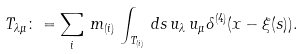Convert formula to latex. <formula><loc_0><loc_0><loc_500><loc_500>T _ { \lambda \mu } \colon = \sum _ { i } \, m _ { ( i ) } \, \int _ { T _ { ( i ) } } \, d s \, u _ { \lambda } \, u _ { \mu } \delta ^ { ( 4 ) } ( x - \xi ( s ) ) .</formula> 